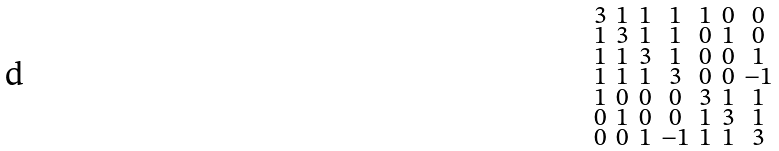Convert formula to latex. <formula><loc_0><loc_0><loc_500><loc_500>\begin{smallmatrix} 3 & 1 & 1 & 1 & 1 & 0 & 0 \\ 1 & 3 & 1 & 1 & 0 & 1 & 0 \\ 1 & 1 & 3 & 1 & 0 & 0 & 1 \\ 1 & 1 & 1 & 3 & 0 & 0 & - 1 \\ 1 & 0 & 0 & 0 & 3 & 1 & 1 \\ 0 & 1 & 0 & 0 & 1 & 3 & 1 \\ 0 & 0 & 1 & - 1 & 1 & 1 & 3 \end{smallmatrix}</formula> 